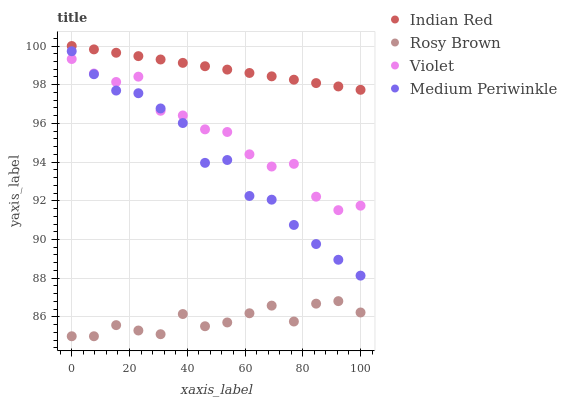Does Rosy Brown have the minimum area under the curve?
Answer yes or no. Yes. Does Indian Red have the maximum area under the curve?
Answer yes or no. Yes. Does Medium Periwinkle have the minimum area under the curve?
Answer yes or no. No. Does Medium Periwinkle have the maximum area under the curve?
Answer yes or no. No. Is Indian Red the smoothest?
Answer yes or no. Yes. Is Violet the roughest?
Answer yes or no. Yes. Is Medium Periwinkle the smoothest?
Answer yes or no. No. Is Medium Periwinkle the roughest?
Answer yes or no. No. Does Rosy Brown have the lowest value?
Answer yes or no. Yes. Does Medium Periwinkle have the lowest value?
Answer yes or no. No. Does Indian Red have the highest value?
Answer yes or no. Yes. Does Medium Periwinkle have the highest value?
Answer yes or no. No. Is Rosy Brown less than Indian Red?
Answer yes or no. Yes. Is Medium Periwinkle greater than Rosy Brown?
Answer yes or no. Yes. Does Violet intersect Medium Periwinkle?
Answer yes or no. Yes. Is Violet less than Medium Periwinkle?
Answer yes or no. No. Is Violet greater than Medium Periwinkle?
Answer yes or no. No. Does Rosy Brown intersect Indian Red?
Answer yes or no. No. 